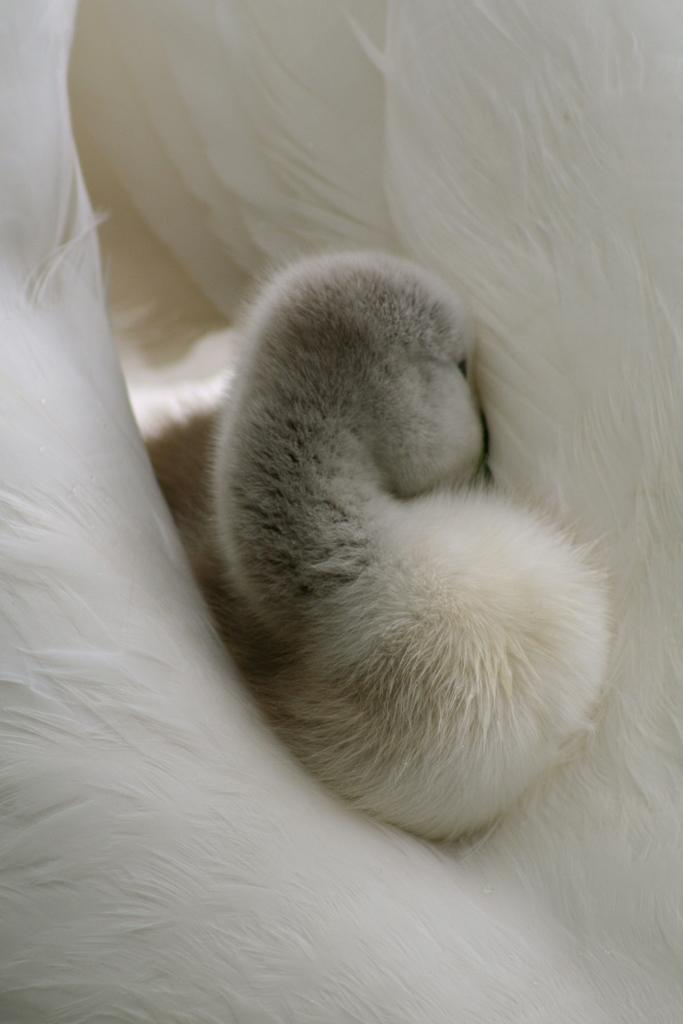What type of animal is in the image? There is a small puppy in the image. Where is the puppy located? The puppy is on a couch. How does the puppy need to fly to reach the top of the couch? The puppy does not need to fly to reach the top of the couch, as it is already on the couch. 